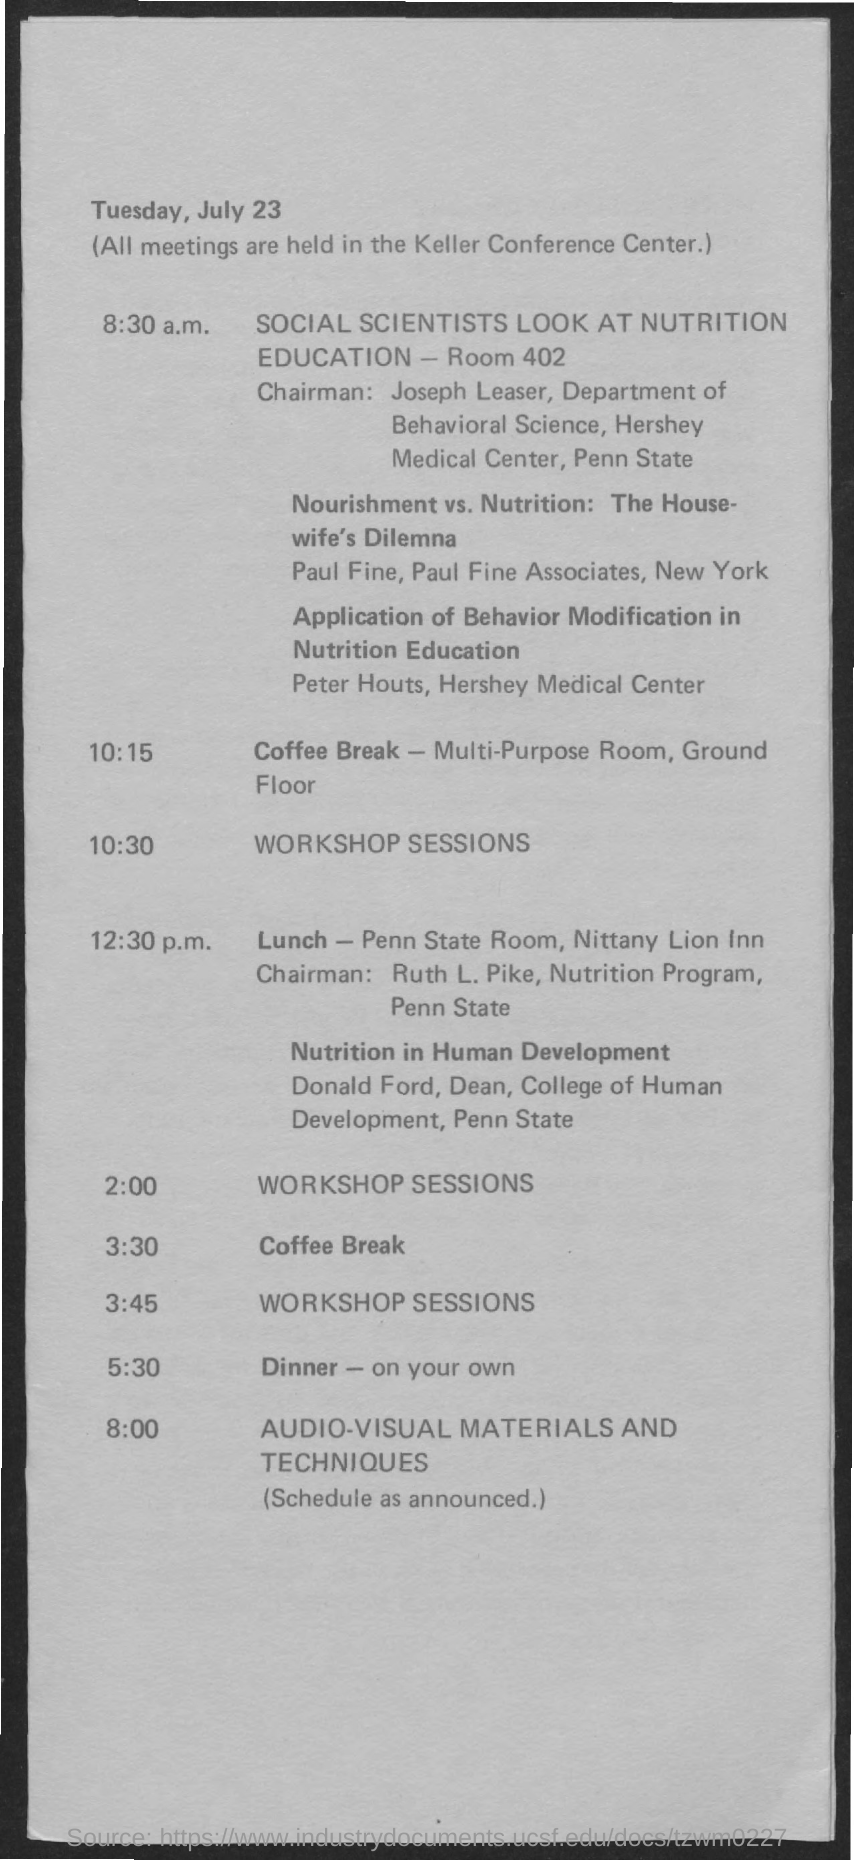On which date the meetings were held ?
Offer a terse response. Tuesday, July 23. To which department joseph leaser belongs to ?
Give a very brief answer. Department of behavioral science. At what time social scientists look at nutrition education ?
Your answer should be compact. 8:30 am. In which room coffee break is given ?
Offer a very short reply. Multi-Purpose Room, Ground Floor. What is the schedule at the time of 10:30 ?
Offer a terse response. Workshop Sessions. What is the dinner time as per the given schedule ?
Your response must be concise. 5:30. What is the time of the lunch as per the given schedule ?
Your response must be concise. 12:30 pm. What is the name of the center at which all meetings were held ?
Make the answer very short. Keller conference center. 